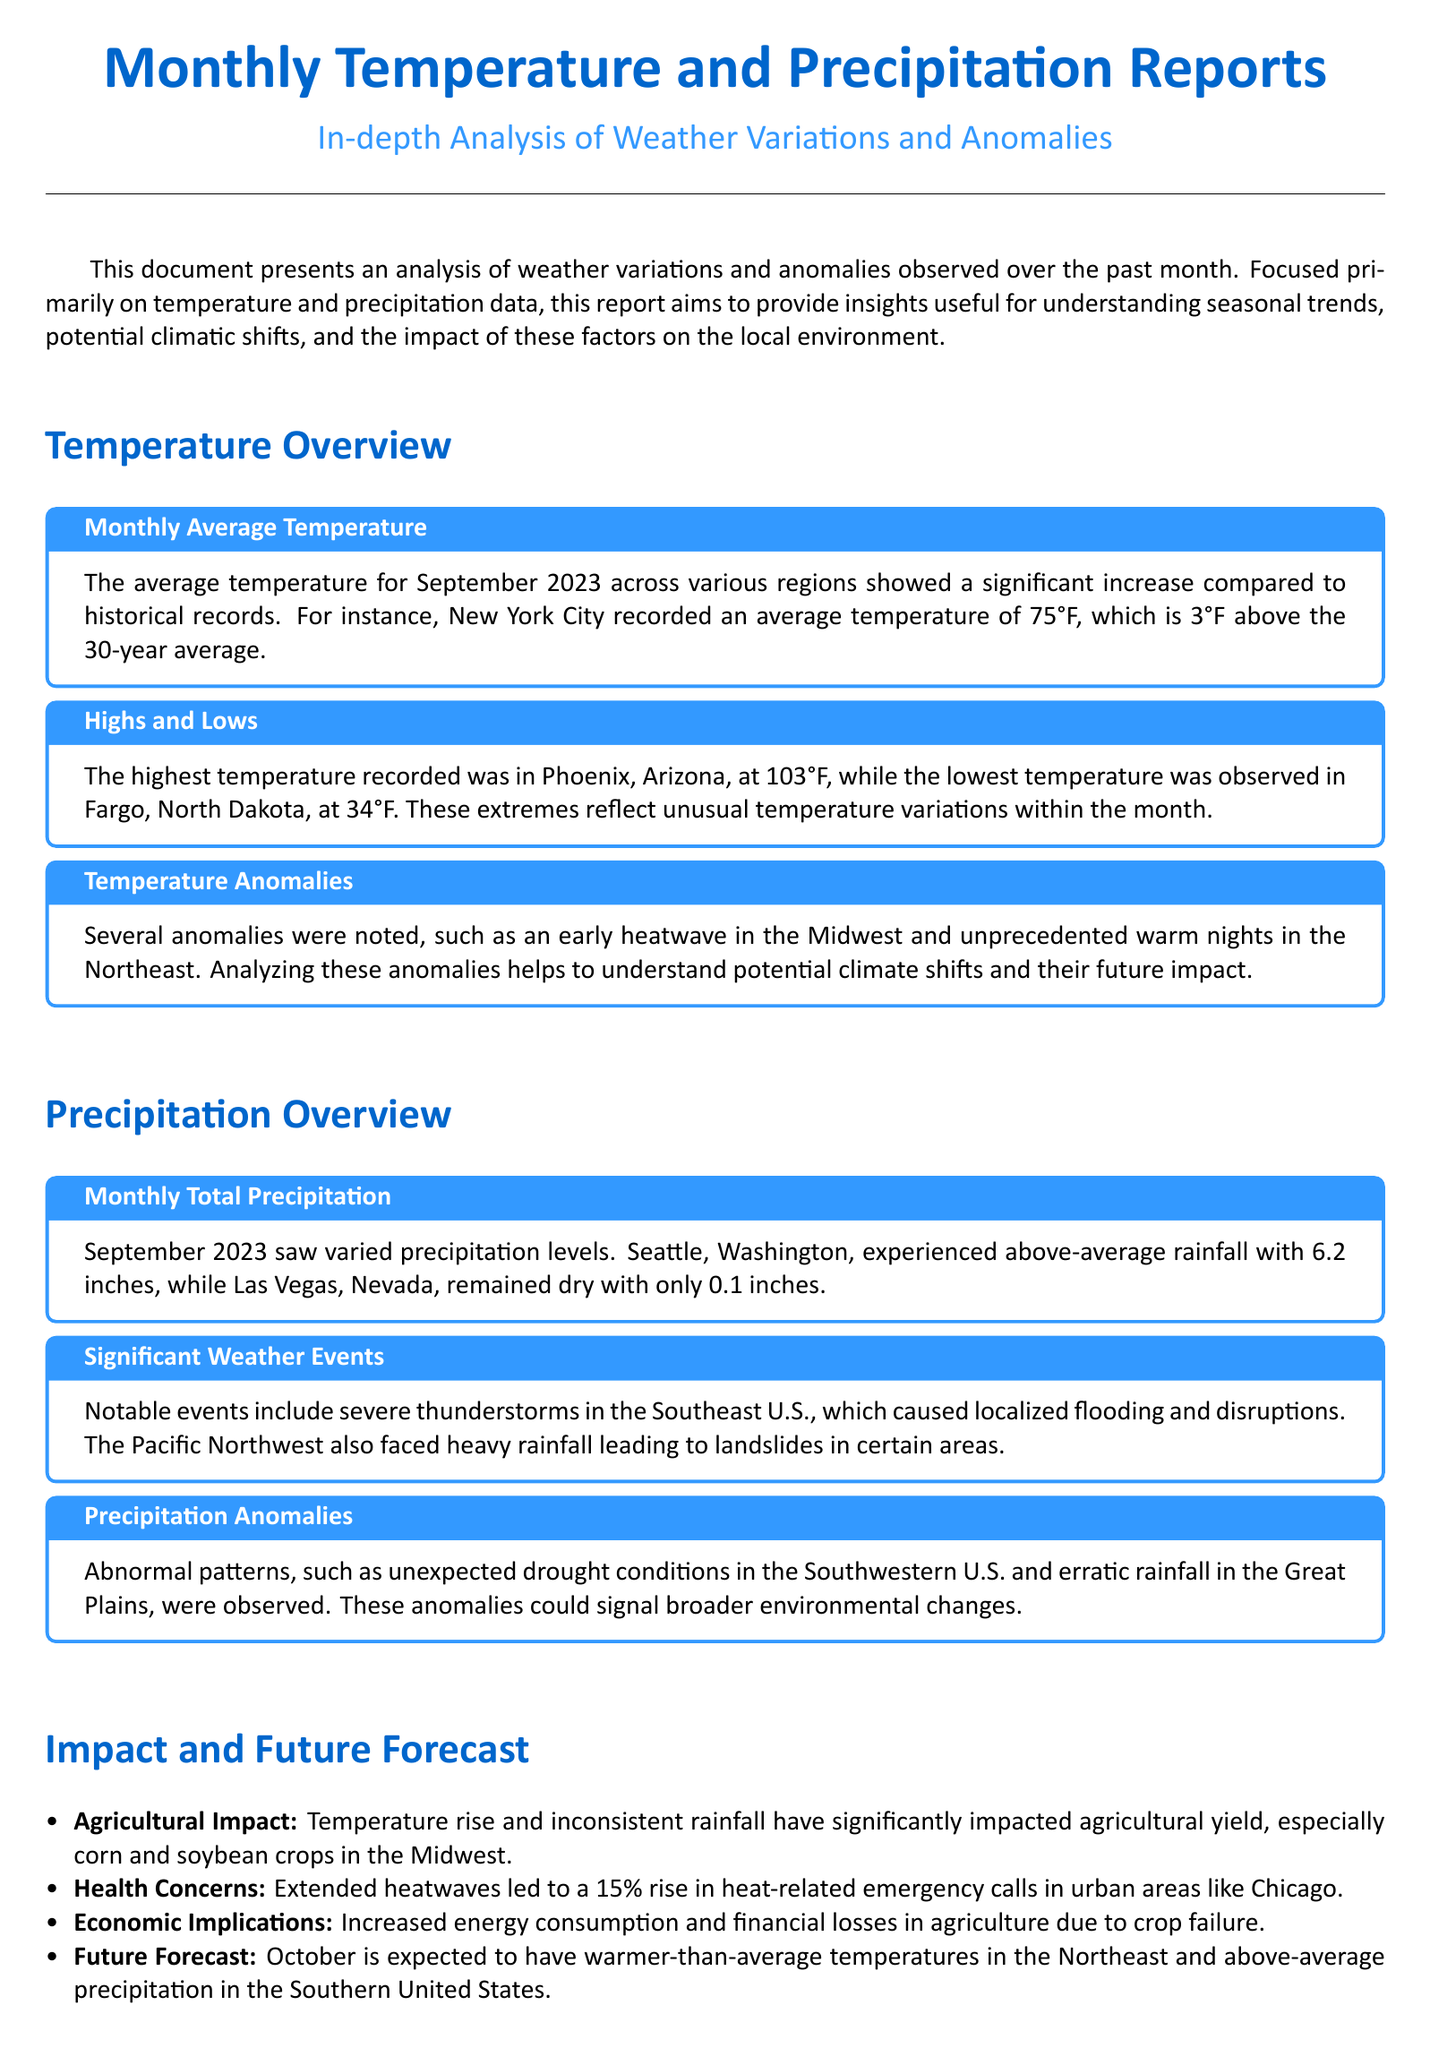What was the average temperature in New York City for September 2023? The document states that New York City recorded an average temperature of 75°F.
Answer: 75°F What was the highest temperature recorded in September 2023? According to the report, the highest temperature recorded was in Phoenix, Arizona, at 103°F.
Answer: 103°F What was the total precipitation in Seattle for September 2023? The document indicates that Seattle, Washington, experienced 6.2 inches of rainfall.
Answer: 6.2 inches What is one example of a significant weather event mentioned in the report? Notable events include severe thunderstorms in the Southeast U.S. causing localized flooding.
Answer: Severe thunderstorms What rise in heat-related emergency calls was reported in urban areas like Chicago? The report states that there was a 15% rise in heat-related emergency calls.
Answer: 15% What anomalies were observed in the Southwestern U.S.? The document notes that unexpected drought conditions were observed.
Answer: Drought conditions Which crops were significantly impacted due to temperature rise and inconsistent rainfall? The document mentions that corn and soybean crops in the Midwest were impacted.
Answer: Corn and soybean What is the forecast for temperatures in October in the Northeast? The report mentions that October is expected to have warmer-than-average temperatures in the Northeast.
Answer: Warmer-than-average What does the report say about the economic implications due to agricultural impacts? It indicates there are increased financial losses in agriculture due to crop failure.
Answer: Financial losses 